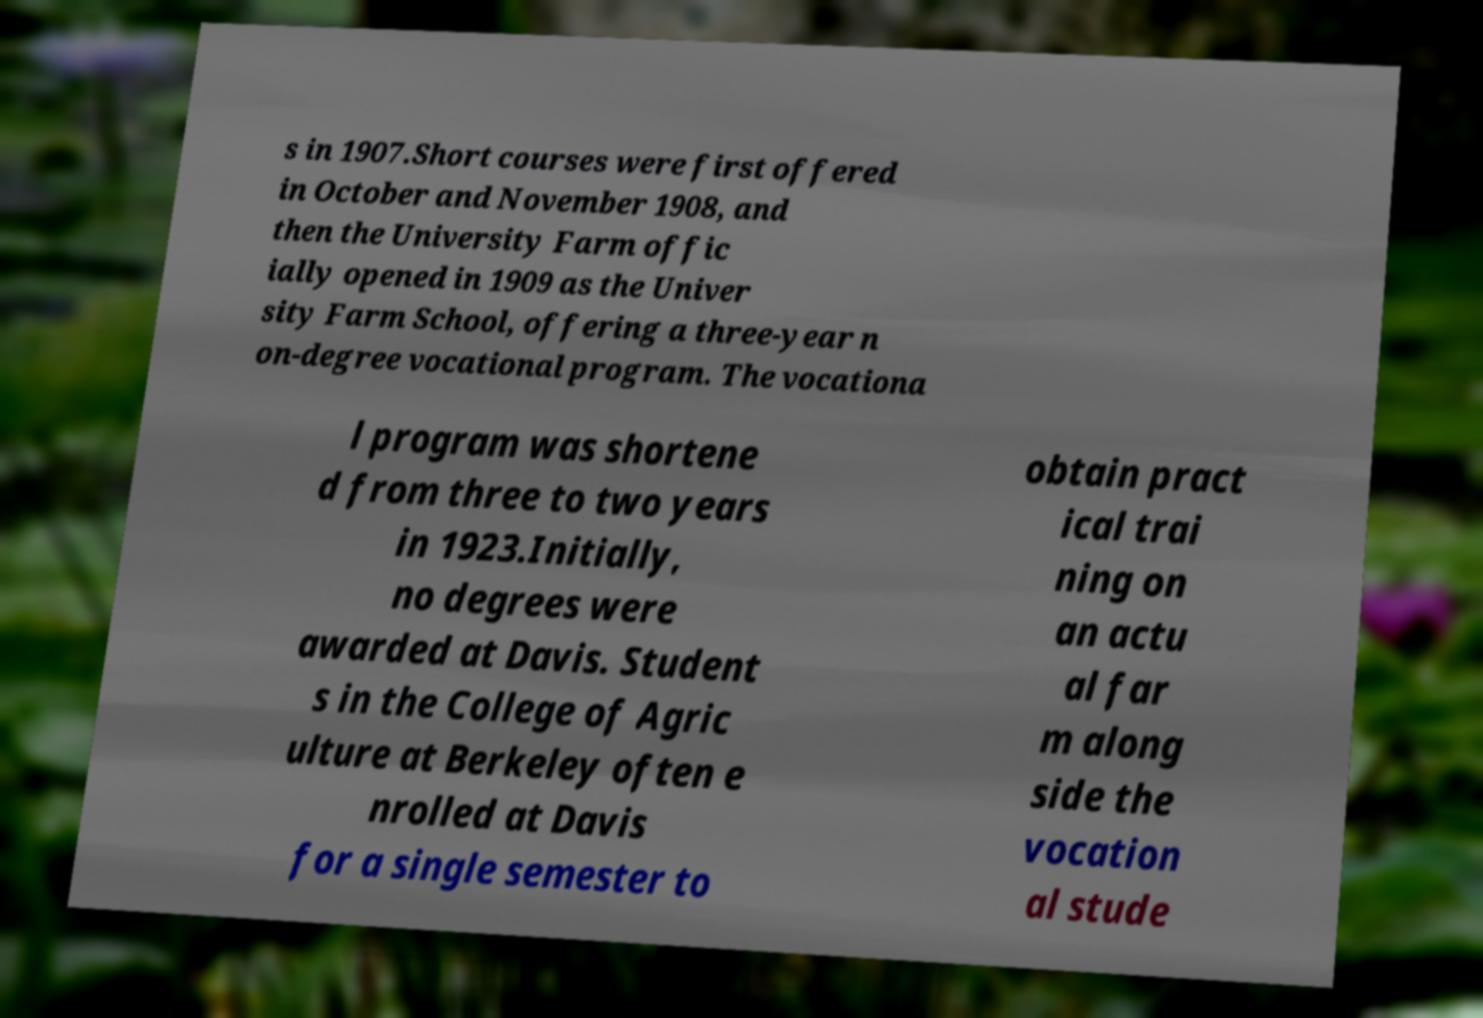I need the written content from this picture converted into text. Can you do that? s in 1907.Short courses were first offered in October and November 1908, and then the University Farm offic ially opened in 1909 as the Univer sity Farm School, offering a three-year n on-degree vocational program. The vocationa l program was shortene d from three to two years in 1923.Initially, no degrees were awarded at Davis. Student s in the College of Agric ulture at Berkeley often e nrolled at Davis for a single semester to obtain pract ical trai ning on an actu al far m along side the vocation al stude 